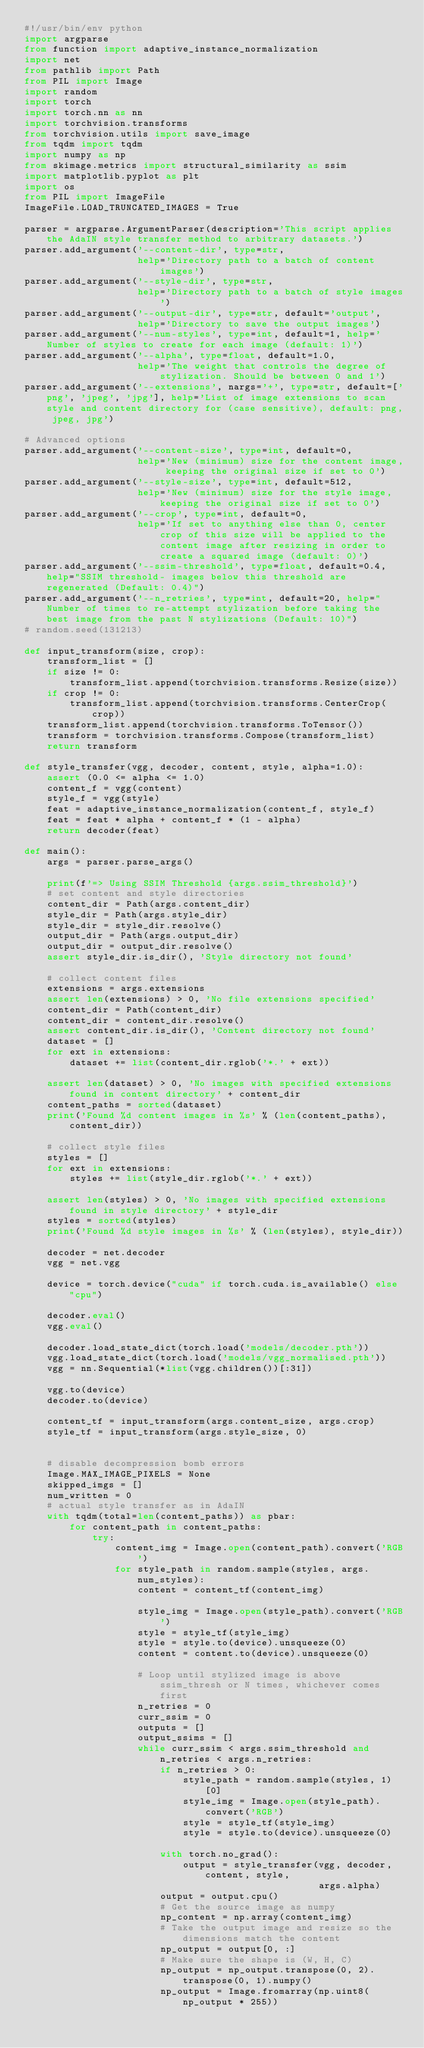Convert code to text. <code><loc_0><loc_0><loc_500><loc_500><_Python_>#!/usr/bin/env python
import argparse
from function import adaptive_instance_normalization
import net
from pathlib import Path
from PIL import Image
import random
import torch
import torch.nn as nn
import torchvision.transforms
from torchvision.utils import save_image
from tqdm import tqdm
import numpy as np
from skimage.metrics import structural_similarity as ssim
import matplotlib.pyplot as plt
import os
from PIL import ImageFile
ImageFile.LOAD_TRUNCATED_IMAGES = True

parser = argparse.ArgumentParser(description='This script applies the AdaIN style transfer method to arbitrary datasets.')
parser.add_argument('--content-dir', type=str,
                    help='Directory path to a batch of content images')
parser.add_argument('--style-dir', type=str,
                    help='Directory path to a batch of style images')
parser.add_argument('--output-dir', type=str, default='output',
                    help='Directory to save the output images')
parser.add_argument('--num-styles', type=int, default=1, help='Number of styles to create for each image (default: 1)')
parser.add_argument('--alpha', type=float, default=1.0,
                    help='The weight that controls the degree of stylization. Should be between 0 and 1')
parser.add_argument('--extensions', nargs='+', type=str, default=['png', 'jpeg', 'jpg'], help='List of image extensions to scan style and content directory for (case sensitive), default: png, jpeg, jpg')

# Advanced options
parser.add_argument('--content-size', type=int, default=0,
                    help='New (minimum) size for the content image, keeping the original size if set to 0')
parser.add_argument('--style-size', type=int, default=512,
                    help='New (minimum) size for the style image, keeping the original size if set to 0')
parser.add_argument('--crop', type=int, default=0,
                    help='If set to anything else than 0, center crop of this size will be applied to the content image after resizing in order to create a squared image (default: 0)')
parser.add_argument('--ssim-threshold', type=float, default=0.4, help="SSIM threshold- images below this threshold are regenerated (Default: 0.4)")
parser.add_argument('--n_retries', type=int, default=20, help="Number of times to re-attempt stylization before taking the best image from the past N stylizations (Default: 10)")
# random.seed(131213)

def input_transform(size, crop):
    transform_list = []
    if size != 0:
        transform_list.append(torchvision.transforms.Resize(size))
    if crop != 0:
        transform_list.append(torchvision.transforms.CenterCrop(crop))
    transform_list.append(torchvision.transforms.ToTensor())
    transform = torchvision.transforms.Compose(transform_list)
    return transform

def style_transfer(vgg, decoder, content, style, alpha=1.0):
    assert (0.0 <= alpha <= 1.0)
    content_f = vgg(content)
    style_f = vgg(style)
    feat = adaptive_instance_normalization(content_f, style_f)
    feat = feat * alpha + content_f * (1 - alpha)
    return decoder(feat)

def main():
    args = parser.parse_args()

    print(f'=> Using SSIM Threshold {args.ssim_threshold}')
    # set content and style directories
    content_dir = Path(args.content_dir)
    style_dir = Path(args.style_dir)
    style_dir = style_dir.resolve()
    output_dir = Path(args.output_dir)
    output_dir = output_dir.resolve()
    assert style_dir.is_dir(), 'Style directory not found'

    # collect content files
    extensions = args.extensions
    assert len(extensions) > 0, 'No file extensions specified'
    content_dir = Path(content_dir)
    content_dir = content_dir.resolve()
    assert content_dir.is_dir(), 'Content directory not found'
    dataset = []
    for ext in extensions:
        dataset += list(content_dir.rglob('*.' + ext))

    assert len(dataset) > 0, 'No images with specified extensions found in content directory' + content_dir
    content_paths = sorted(dataset)
    print('Found %d content images in %s' % (len(content_paths), content_dir))

    # collect style files
    styles = []
    for ext in extensions:
        styles += list(style_dir.rglob('*.' + ext))

    assert len(styles) > 0, 'No images with specified extensions found in style directory' + style_dir
    styles = sorted(styles)
    print('Found %d style images in %s' % (len(styles), style_dir))

    decoder = net.decoder
    vgg = net.vgg

    device = torch.device("cuda" if torch.cuda.is_available() else "cpu")

    decoder.eval()
    vgg.eval()

    decoder.load_state_dict(torch.load('models/decoder.pth'))
    vgg.load_state_dict(torch.load('models/vgg_normalised.pth'))
    vgg = nn.Sequential(*list(vgg.children())[:31])

    vgg.to(device)
    decoder.to(device)

    content_tf = input_transform(args.content_size, args.crop)
    style_tf = input_transform(args.style_size, 0)


    # disable decompression bomb errors
    Image.MAX_IMAGE_PIXELS = None
    skipped_imgs = []
    num_written = 0
    # actual style transfer as in AdaIN
    with tqdm(total=len(content_paths)) as pbar:
        for content_path in content_paths:
            try:
                content_img = Image.open(content_path).convert('RGB')
                for style_path in random.sample(styles, args.num_styles):
                    content = content_tf(content_img)

                    style_img = Image.open(style_path).convert('RGB')
                    style = style_tf(style_img)
                    style = style.to(device).unsqueeze(0)
                    content = content.to(device).unsqueeze(0)

                    # Loop until stylized image is above ssim_thresh or N times, whichever comes first
                    n_retries = 0
                    curr_ssim = 0
                    outputs = []
                    output_ssims = []
                    while curr_ssim < args.ssim_threshold and n_retries < args.n_retries:
                        if n_retries > 0:
                            style_path = random.sample(styles, 1)[0]
                            style_img = Image.open(style_path).convert('RGB')
                            style = style_tf(style_img)
                            style = style.to(device).unsqueeze(0)

                        with torch.no_grad():
                            output = style_transfer(vgg, decoder, content, style,
                                                    args.alpha)
                        output = output.cpu()
                        # Get the source image as numpy
                        np_content = np.array(content_img)
                        # Take the output image and resize so the dimensions match the content
                        np_output = output[0, :]
                        # Make sure the shape is (W, H, C)
                        np_output = np_output.transpose(0, 2).transpose(0, 1).numpy()
                        np_output = Image.fromarray(np.uint8(np_output * 255))</code> 